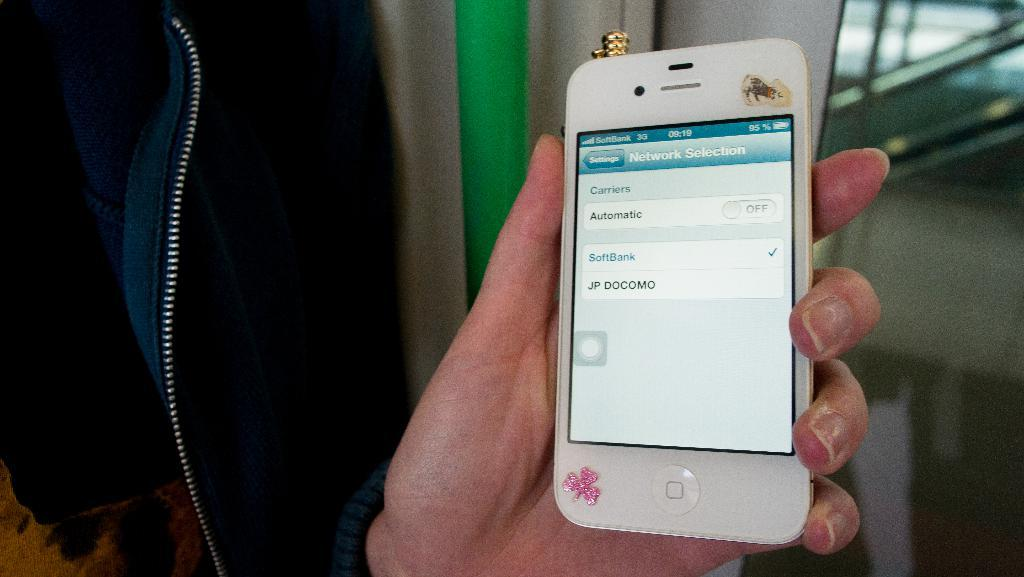What object is being held by a human hand in the image? There is a mobile in the image, and it is being held by a human hand. What can be seen on the mobile screen? There is text visible on the mobile screen. What color is the pole in the background of the image? There is a green color pole in the background of the image. Are there any bears wearing a veil in the image? No, there are no bears or veils present in the image. What type of pin can be seen holding the mobile to the pole? There is no pin visible in the image; the mobile is being held by a human hand. 